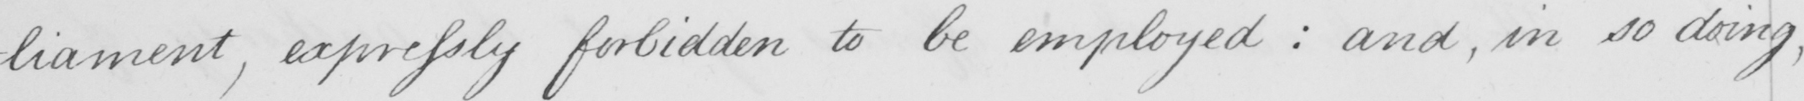Can you read and transcribe this handwriting? -liament , expressly forbidden to be employed :  and , in so doing , 